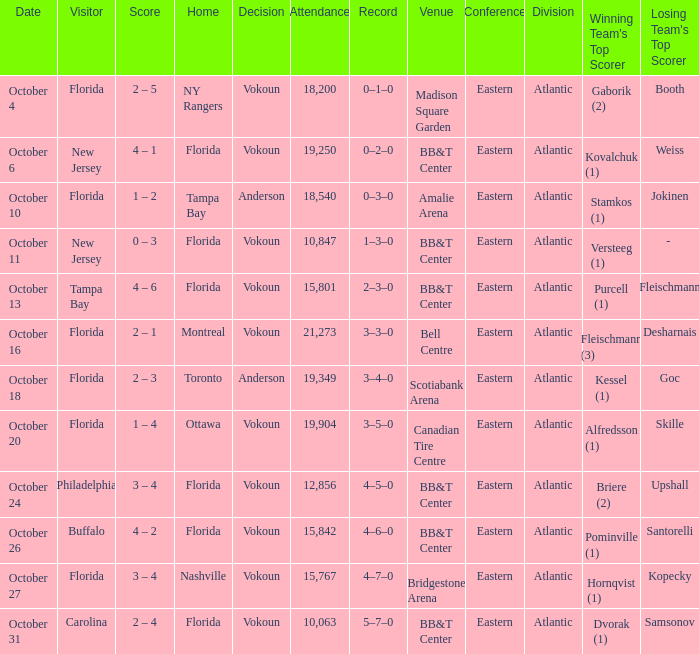Which team won when the visitor was Carolina? Vokoun. 